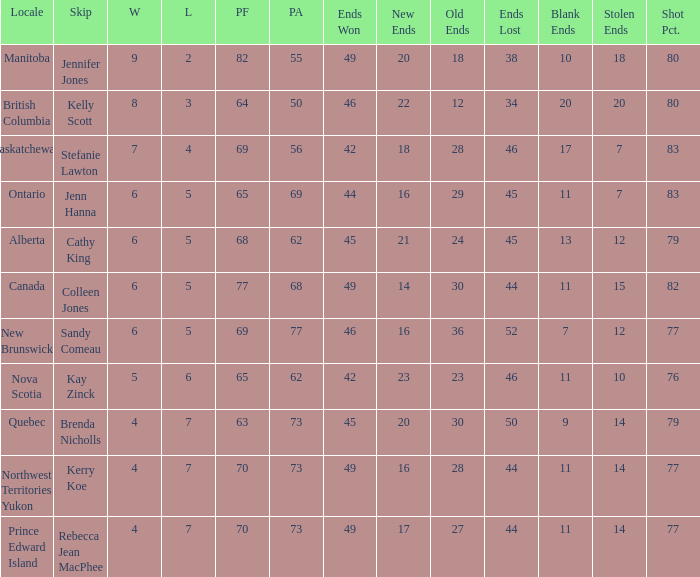What is the total number of ends won when the locale is Northwest Territories Yukon? 1.0. 